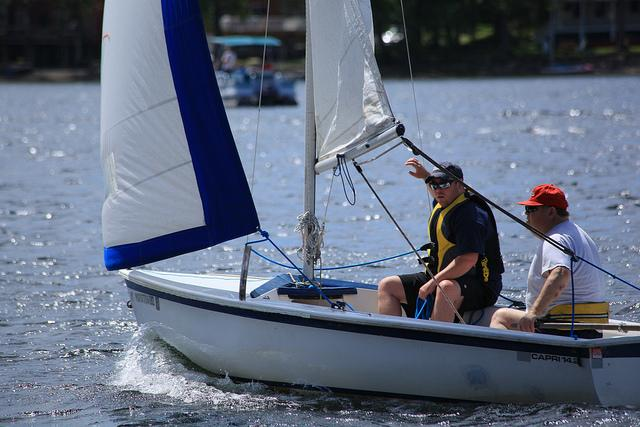What color is the border of the sail on the small boat?

Choices:
A) yellow
B) red
C) blue
D) green blue 